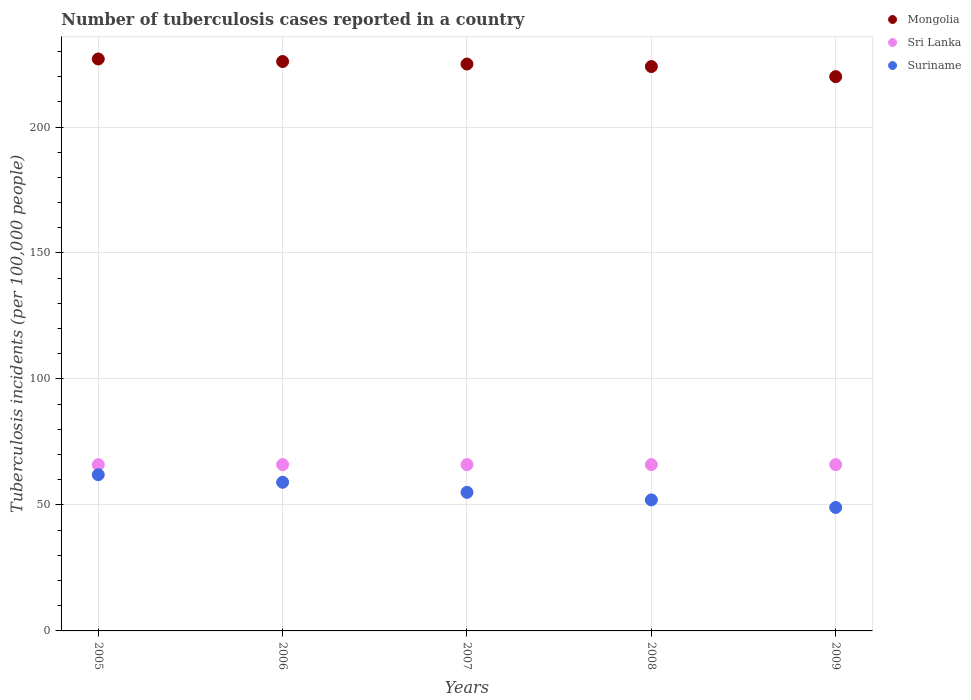Is the number of dotlines equal to the number of legend labels?
Ensure brevity in your answer.  Yes. What is the number of tuberculosis cases reported in in Suriname in 2009?
Offer a very short reply. 49. Across all years, what is the maximum number of tuberculosis cases reported in in Mongolia?
Keep it short and to the point. 227. Across all years, what is the minimum number of tuberculosis cases reported in in Suriname?
Ensure brevity in your answer.  49. In which year was the number of tuberculosis cases reported in in Sri Lanka maximum?
Offer a very short reply. 2005. In which year was the number of tuberculosis cases reported in in Suriname minimum?
Make the answer very short. 2009. What is the total number of tuberculosis cases reported in in Suriname in the graph?
Provide a short and direct response. 277. What is the difference between the number of tuberculosis cases reported in in Mongolia in 2005 and that in 2006?
Ensure brevity in your answer.  1. What is the difference between the number of tuberculosis cases reported in in Suriname in 2006 and the number of tuberculosis cases reported in in Sri Lanka in 2005?
Make the answer very short. -7. What is the average number of tuberculosis cases reported in in Sri Lanka per year?
Your answer should be very brief. 66. In the year 2008, what is the difference between the number of tuberculosis cases reported in in Sri Lanka and number of tuberculosis cases reported in in Suriname?
Offer a very short reply. 14. In how many years, is the number of tuberculosis cases reported in in Suriname greater than 200?
Your answer should be very brief. 0. What is the ratio of the number of tuberculosis cases reported in in Suriname in 2006 to that in 2007?
Your answer should be very brief. 1.07. Is the difference between the number of tuberculosis cases reported in in Sri Lanka in 2007 and 2009 greater than the difference between the number of tuberculosis cases reported in in Suriname in 2007 and 2009?
Your response must be concise. No. What is the difference between the highest and the second highest number of tuberculosis cases reported in in Mongolia?
Your answer should be compact. 1. What is the difference between the highest and the lowest number of tuberculosis cases reported in in Mongolia?
Ensure brevity in your answer.  7. In how many years, is the number of tuberculosis cases reported in in Mongolia greater than the average number of tuberculosis cases reported in in Mongolia taken over all years?
Provide a succinct answer. 3. Is the sum of the number of tuberculosis cases reported in in Mongolia in 2006 and 2008 greater than the maximum number of tuberculosis cases reported in in Sri Lanka across all years?
Keep it short and to the point. Yes. Is it the case that in every year, the sum of the number of tuberculosis cases reported in in Mongolia and number of tuberculosis cases reported in in Sri Lanka  is greater than the number of tuberculosis cases reported in in Suriname?
Your answer should be very brief. Yes. Does the number of tuberculosis cases reported in in Mongolia monotonically increase over the years?
Your answer should be very brief. No. Is the number of tuberculosis cases reported in in Mongolia strictly greater than the number of tuberculosis cases reported in in Sri Lanka over the years?
Your answer should be compact. Yes. How many dotlines are there?
Keep it short and to the point. 3. How many years are there in the graph?
Offer a very short reply. 5. What is the difference between two consecutive major ticks on the Y-axis?
Make the answer very short. 50. How are the legend labels stacked?
Make the answer very short. Vertical. What is the title of the graph?
Give a very brief answer. Number of tuberculosis cases reported in a country. What is the label or title of the Y-axis?
Provide a succinct answer. Tuberculosis incidents (per 100,0 people). What is the Tuberculosis incidents (per 100,000 people) of Mongolia in 2005?
Ensure brevity in your answer.  227. What is the Tuberculosis incidents (per 100,000 people) of Suriname in 2005?
Keep it short and to the point. 62. What is the Tuberculosis incidents (per 100,000 people) of Mongolia in 2006?
Offer a terse response. 226. What is the Tuberculosis incidents (per 100,000 people) of Sri Lanka in 2006?
Offer a very short reply. 66. What is the Tuberculosis incidents (per 100,000 people) of Mongolia in 2007?
Offer a very short reply. 225. What is the Tuberculosis incidents (per 100,000 people) of Sri Lanka in 2007?
Your answer should be compact. 66. What is the Tuberculosis incidents (per 100,000 people) in Suriname in 2007?
Give a very brief answer. 55. What is the Tuberculosis incidents (per 100,000 people) of Mongolia in 2008?
Make the answer very short. 224. What is the Tuberculosis incidents (per 100,000 people) in Sri Lanka in 2008?
Provide a short and direct response. 66. What is the Tuberculosis incidents (per 100,000 people) in Mongolia in 2009?
Ensure brevity in your answer.  220. Across all years, what is the maximum Tuberculosis incidents (per 100,000 people) of Mongolia?
Keep it short and to the point. 227. Across all years, what is the maximum Tuberculosis incidents (per 100,000 people) of Sri Lanka?
Your answer should be compact. 66. Across all years, what is the maximum Tuberculosis incidents (per 100,000 people) of Suriname?
Make the answer very short. 62. Across all years, what is the minimum Tuberculosis incidents (per 100,000 people) of Mongolia?
Offer a terse response. 220. Across all years, what is the minimum Tuberculosis incidents (per 100,000 people) in Suriname?
Your answer should be very brief. 49. What is the total Tuberculosis incidents (per 100,000 people) of Mongolia in the graph?
Your response must be concise. 1122. What is the total Tuberculosis incidents (per 100,000 people) in Sri Lanka in the graph?
Make the answer very short. 330. What is the total Tuberculosis incidents (per 100,000 people) of Suriname in the graph?
Your response must be concise. 277. What is the difference between the Tuberculosis incidents (per 100,000 people) of Sri Lanka in 2005 and that in 2006?
Offer a very short reply. 0. What is the difference between the Tuberculosis incidents (per 100,000 people) in Mongolia in 2005 and that in 2009?
Offer a terse response. 7. What is the difference between the Tuberculosis incidents (per 100,000 people) in Sri Lanka in 2005 and that in 2009?
Make the answer very short. 0. What is the difference between the Tuberculosis incidents (per 100,000 people) in Suriname in 2005 and that in 2009?
Give a very brief answer. 13. What is the difference between the Tuberculosis incidents (per 100,000 people) in Mongolia in 2006 and that in 2007?
Keep it short and to the point. 1. What is the difference between the Tuberculosis incidents (per 100,000 people) of Sri Lanka in 2006 and that in 2007?
Offer a terse response. 0. What is the difference between the Tuberculosis incidents (per 100,000 people) in Mongolia in 2006 and that in 2008?
Your response must be concise. 2. What is the difference between the Tuberculosis incidents (per 100,000 people) in Sri Lanka in 2006 and that in 2009?
Provide a short and direct response. 0. What is the difference between the Tuberculosis incidents (per 100,000 people) in Mongolia in 2007 and that in 2008?
Provide a short and direct response. 1. What is the difference between the Tuberculosis incidents (per 100,000 people) of Sri Lanka in 2007 and that in 2008?
Provide a succinct answer. 0. What is the difference between the Tuberculosis incidents (per 100,000 people) of Sri Lanka in 2008 and that in 2009?
Ensure brevity in your answer.  0. What is the difference between the Tuberculosis incidents (per 100,000 people) of Suriname in 2008 and that in 2009?
Provide a succinct answer. 3. What is the difference between the Tuberculosis incidents (per 100,000 people) in Mongolia in 2005 and the Tuberculosis incidents (per 100,000 people) in Sri Lanka in 2006?
Your response must be concise. 161. What is the difference between the Tuberculosis incidents (per 100,000 people) in Mongolia in 2005 and the Tuberculosis incidents (per 100,000 people) in Suriname in 2006?
Provide a short and direct response. 168. What is the difference between the Tuberculosis incidents (per 100,000 people) in Sri Lanka in 2005 and the Tuberculosis incidents (per 100,000 people) in Suriname in 2006?
Your response must be concise. 7. What is the difference between the Tuberculosis incidents (per 100,000 people) in Mongolia in 2005 and the Tuberculosis incidents (per 100,000 people) in Sri Lanka in 2007?
Your answer should be compact. 161. What is the difference between the Tuberculosis incidents (per 100,000 people) of Mongolia in 2005 and the Tuberculosis incidents (per 100,000 people) of Suriname in 2007?
Your response must be concise. 172. What is the difference between the Tuberculosis incidents (per 100,000 people) of Mongolia in 2005 and the Tuberculosis incidents (per 100,000 people) of Sri Lanka in 2008?
Make the answer very short. 161. What is the difference between the Tuberculosis incidents (per 100,000 people) of Mongolia in 2005 and the Tuberculosis incidents (per 100,000 people) of Suriname in 2008?
Keep it short and to the point. 175. What is the difference between the Tuberculosis incidents (per 100,000 people) in Mongolia in 2005 and the Tuberculosis incidents (per 100,000 people) in Sri Lanka in 2009?
Provide a short and direct response. 161. What is the difference between the Tuberculosis incidents (per 100,000 people) in Mongolia in 2005 and the Tuberculosis incidents (per 100,000 people) in Suriname in 2009?
Keep it short and to the point. 178. What is the difference between the Tuberculosis incidents (per 100,000 people) of Mongolia in 2006 and the Tuberculosis incidents (per 100,000 people) of Sri Lanka in 2007?
Your answer should be very brief. 160. What is the difference between the Tuberculosis incidents (per 100,000 people) of Mongolia in 2006 and the Tuberculosis incidents (per 100,000 people) of Suriname in 2007?
Give a very brief answer. 171. What is the difference between the Tuberculosis incidents (per 100,000 people) of Mongolia in 2006 and the Tuberculosis incidents (per 100,000 people) of Sri Lanka in 2008?
Your answer should be compact. 160. What is the difference between the Tuberculosis incidents (per 100,000 people) of Mongolia in 2006 and the Tuberculosis incidents (per 100,000 people) of Suriname in 2008?
Your answer should be very brief. 174. What is the difference between the Tuberculosis incidents (per 100,000 people) in Sri Lanka in 2006 and the Tuberculosis incidents (per 100,000 people) in Suriname in 2008?
Make the answer very short. 14. What is the difference between the Tuberculosis incidents (per 100,000 people) of Mongolia in 2006 and the Tuberculosis incidents (per 100,000 people) of Sri Lanka in 2009?
Make the answer very short. 160. What is the difference between the Tuberculosis incidents (per 100,000 people) in Mongolia in 2006 and the Tuberculosis incidents (per 100,000 people) in Suriname in 2009?
Offer a very short reply. 177. What is the difference between the Tuberculosis incidents (per 100,000 people) of Mongolia in 2007 and the Tuberculosis incidents (per 100,000 people) of Sri Lanka in 2008?
Your answer should be compact. 159. What is the difference between the Tuberculosis incidents (per 100,000 people) of Mongolia in 2007 and the Tuberculosis incidents (per 100,000 people) of Suriname in 2008?
Your response must be concise. 173. What is the difference between the Tuberculosis incidents (per 100,000 people) of Sri Lanka in 2007 and the Tuberculosis incidents (per 100,000 people) of Suriname in 2008?
Your answer should be very brief. 14. What is the difference between the Tuberculosis incidents (per 100,000 people) of Mongolia in 2007 and the Tuberculosis incidents (per 100,000 people) of Sri Lanka in 2009?
Offer a terse response. 159. What is the difference between the Tuberculosis incidents (per 100,000 people) of Mongolia in 2007 and the Tuberculosis incidents (per 100,000 people) of Suriname in 2009?
Provide a succinct answer. 176. What is the difference between the Tuberculosis incidents (per 100,000 people) of Mongolia in 2008 and the Tuberculosis incidents (per 100,000 people) of Sri Lanka in 2009?
Offer a terse response. 158. What is the difference between the Tuberculosis incidents (per 100,000 people) in Mongolia in 2008 and the Tuberculosis incidents (per 100,000 people) in Suriname in 2009?
Keep it short and to the point. 175. What is the difference between the Tuberculosis incidents (per 100,000 people) of Sri Lanka in 2008 and the Tuberculosis incidents (per 100,000 people) of Suriname in 2009?
Offer a very short reply. 17. What is the average Tuberculosis incidents (per 100,000 people) in Mongolia per year?
Provide a succinct answer. 224.4. What is the average Tuberculosis incidents (per 100,000 people) of Sri Lanka per year?
Give a very brief answer. 66. What is the average Tuberculosis incidents (per 100,000 people) of Suriname per year?
Keep it short and to the point. 55.4. In the year 2005, what is the difference between the Tuberculosis incidents (per 100,000 people) in Mongolia and Tuberculosis incidents (per 100,000 people) in Sri Lanka?
Provide a short and direct response. 161. In the year 2005, what is the difference between the Tuberculosis incidents (per 100,000 people) of Mongolia and Tuberculosis incidents (per 100,000 people) of Suriname?
Your answer should be compact. 165. In the year 2005, what is the difference between the Tuberculosis incidents (per 100,000 people) in Sri Lanka and Tuberculosis incidents (per 100,000 people) in Suriname?
Provide a succinct answer. 4. In the year 2006, what is the difference between the Tuberculosis incidents (per 100,000 people) in Mongolia and Tuberculosis incidents (per 100,000 people) in Sri Lanka?
Your answer should be very brief. 160. In the year 2006, what is the difference between the Tuberculosis incidents (per 100,000 people) of Mongolia and Tuberculosis incidents (per 100,000 people) of Suriname?
Offer a terse response. 167. In the year 2006, what is the difference between the Tuberculosis incidents (per 100,000 people) of Sri Lanka and Tuberculosis incidents (per 100,000 people) of Suriname?
Your answer should be compact. 7. In the year 2007, what is the difference between the Tuberculosis incidents (per 100,000 people) in Mongolia and Tuberculosis incidents (per 100,000 people) in Sri Lanka?
Keep it short and to the point. 159. In the year 2007, what is the difference between the Tuberculosis incidents (per 100,000 people) in Mongolia and Tuberculosis incidents (per 100,000 people) in Suriname?
Keep it short and to the point. 170. In the year 2007, what is the difference between the Tuberculosis incidents (per 100,000 people) in Sri Lanka and Tuberculosis incidents (per 100,000 people) in Suriname?
Give a very brief answer. 11. In the year 2008, what is the difference between the Tuberculosis incidents (per 100,000 people) of Mongolia and Tuberculosis incidents (per 100,000 people) of Sri Lanka?
Provide a short and direct response. 158. In the year 2008, what is the difference between the Tuberculosis incidents (per 100,000 people) of Mongolia and Tuberculosis incidents (per 100,000 people) of Suriname?
Ensure brevity in your answer.  172. In the year 2008, what is the difference between the Tuberculosis incidents (per 100,000 people) in Sri Lanka and Tuberculosis incidents (per 100,000 people) in Suriname?
Your response must be concise. 14. In the year 2009, what is the difference between the Tuberculosis incidents (per 100,000 people) in Mongolia and Tuberculosis incidents (per 100,000 people) in Sri Lanka?
Your answer should be very brief. 154. In the year 2009, what is the difference between the Tuberculosis incidents (per 100,000 people) in Mongolia and Tuberculosis incidents (per 100,000 people) in Suriname?
Your response must be concise. 171. What is the ratio of the Tuberculosis incidents (per 100,000 people) of Sri Lanka in 2005 to that in 2006?
Offer a very short reply. 1. What is the ratio of the Tuberculosis incidents (per 100,000 people) of Suriname in 2005 to that in 2006?
Offer a terse response. 1.05. What is the ratio of the Tuberculosis incidents (per 100,000 people) in Mongolia in 2005 to that in 2007?
Provide a short and direct response. 1.01. What is the ratio of the Tuberculosis incidents (per 100,000 people) of Sri Lanka in 2005 to that in 2007?
Offer a very short reply. 1. What is the ratio of the Tuberculosis incidents (per 100,000 people) in Suriname in 2005 to that in 2007?
Provide a short and direct response. 1.13. What is the ratio of the Tuberculosis incidents (per 100,000 people) of Mongolia in 2005 to that in 2008?
Give a very brief answer. 1.01. What is the ratio of the Tuberculosis incidents (per 100,000 people) in Suriname in 2005 to that in 2008?
Your answer should be very brief. 1.19. What is the ratio of the Tuberculosis incidents (per 100,000 people) in Mongolia in 2005 to that in 2009?
Offer a very short reply. 1.03. What is the ratio of the Tuberculosis incidents (per 100,000 people) in Sri Lanka in 2005 to that in 2009?
Provide a short and direct response. 1. What is the ratio of the Tuberculosis incidents (per 100,000 people) in Suriname in 2005 to that in 2009?
Ensure brevity in your answer.  1.27. What is the ratio of the Tuberculosis incidents (per 100,000 people) of Suriname in 2006 to that in 2007?
Make the answer very short. 1.07. What is the ratio of the Tuberculosis incidents (per 100,000 people) in Mongolia in 2006 to that in 2008?
Provide a short and direct response. 1.01. What is the ratio of the Tuberculosis incidents (per 100,000 people) of Sri Lanka in 2006 to that in 2008?
Your answer should be compact. 1. What is the ratio of the Tuberculosis incidents (per 100,000 people) of Suriname in 2006 to that in 2008?
Offer a terse response. 1.13. What is the ratio of the Tuberculosis incidents (per 100,000 people) in Mongolia in 2006 to that in 2009?
Keep it short and to the point. 1.03. What is the ratio of the Tuberculosis incidents (per 100,000 people) of Suriname in 2006 to that in 2009?
Provide a short and direct response. 1.2. What is the ratio of the Tuberculosis incidents (per 100,000 people) of Suriname in 2007 to that in 2008?
Keep it short and to the point. 1.06. What is the ratio of the Tuberculosis incidents (per 100,000 people) in Mongolia in 2007 to that in 2009?
Offer a very short reply. 1.02. What is the ratio of the Tuberculosis incidents (per 100,000 people) of Suriname in 2007 to that in 2009?
Make the answer very short. 1.12. What is the ratio of the Tuberculosis incidents (per 100,000 people) of Mongolia in 2008 to that in 2009?
Offer a very short reply. 1.02. What is the ratio of the Tuberculosis incidents (per 100,000 people) of Suriname in 2008 to that in 2009?
Give a very brief answer. 1.06. What is the difference between the highest and the second highest Tuberculosis incidents (per 100,000 people) in Mongolia?
Ensure brevity in your answer.  1. 